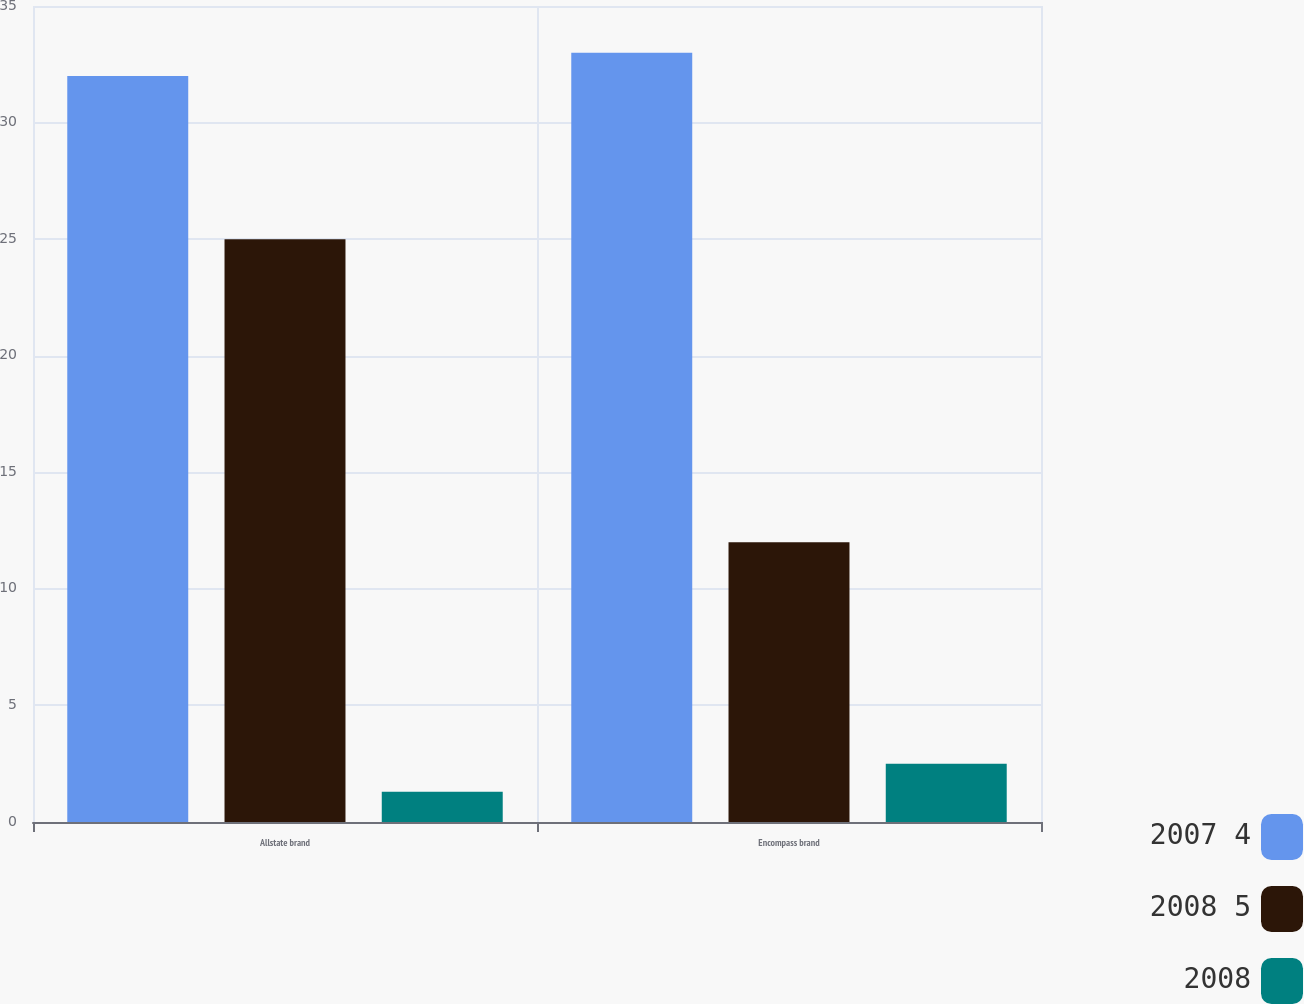Convert chart. <chart><loc_0><loc_0><loc_500><loc_500><stacked_bar_chart><ecel><fcel>Allstate brand<fcel>Encompass brand<nl><fcel>2007 4<fcel>32<fcel>33<nl><fcel>2008 5<fcel>25<fcel>12<nl><fcel>2008<fcel>1.3<fcel>2.5<nl></chart> 